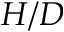Convert formula to latex. <formula><loc_0><loc_0><loc_500><loc_500>H / D</formula> 